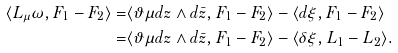Convert formula to latex. <formula><loc_0><loc_0><loc_500><loc_500>\langle L _ { \mu } \omega , F _ { 1 } - F _ { 2 } \rangle = & \langle \vartheta \mu d z \wedge d \bar { z } , F _ { 1 } - F _ { 2 } \rangle - \langle d \xi , F _ { 1 } - F _ { 2 } \rangle \\ = & \langle \vartheta \mu d z \wedge d \bar { z } , F _ { 1 } - F _ { 2 } \rangle - \langle \delta \xi , L _ { 1 } - L _ { 2 } \rangle .</formula> 